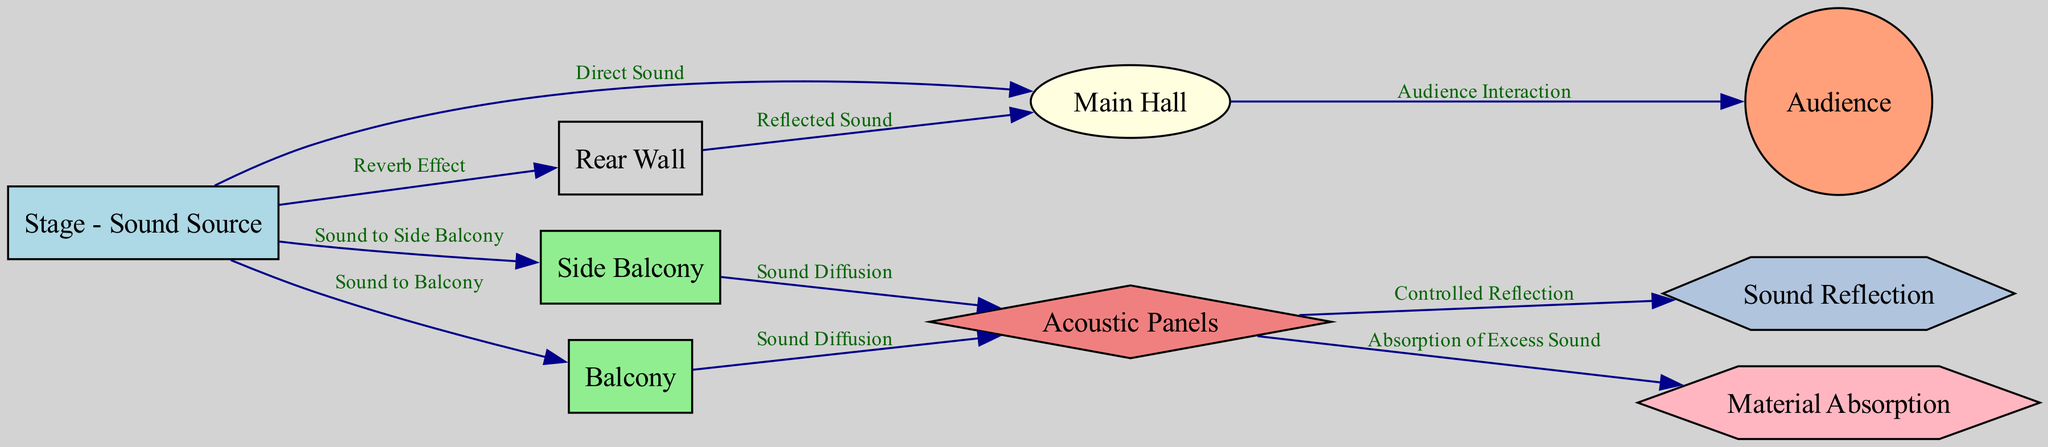What is the main sound source in the diagram? The diagram identifies the "Stage" as the central sound source, indicated by its label.
Answer: Stage - Sound Source How many acoustic panels are there in the diagram? The diagram has one "Acoustic Panels" node, represented as a single entity, without any duplicates.
Answer: 1 What type of sound interaction occurs between the main hall and the audience? The diagram specifies "Audience Interaction" as the connection from "Main Hall" to "Audience," indicating the nature of sound reaching the audience.
Answer: Audience Interaction Which section receives sound directly from the stage aside from the main hall? The diagram shows that both the "Balcony" and "Side Balcony" receive sound directly from the "Stage," as indicated by their direct connections.
Answer: Balcony and Side Balcony What happens to excess sound at the acoustic panels? According to the diagram, the "Acoustic Panels" absorb excess sound, indicated by the labeled edge pointing to "Material Absorption."
Answer: Absorption of Excess Sound What type of effect can sound create when it reaches the rear wall? The diagram explains the sound coming from the stage to the rear wall creates a "Reverb Effect," showing how sound interacts with the hall's architecture.
Answer: Reverb Effect How is sound diffusion facilitated in the diagram? The diagram illustrates that sound diffusion happens from both the "Balcony" and the "Side Balcony" to the "Acoustic Panels," showcasing how sound is spread throughout the hall.
Answer: Sound Diffusion What is the function of the sound reflection indicated in the diagram? The "Controlled Reflection" label in the diagram indicates that part of the sound is reflected back from the acoustic panels, enhancing the sound experience.
Answer: Controlled Reflection Which architectural feature primarily contributes to sound absorption? The diagram indicates that "Acoustic Panels" are the primary feature contributing to sound absorption as they connect to the relevant sound absorption node.
Answer: Acoustic Panels 